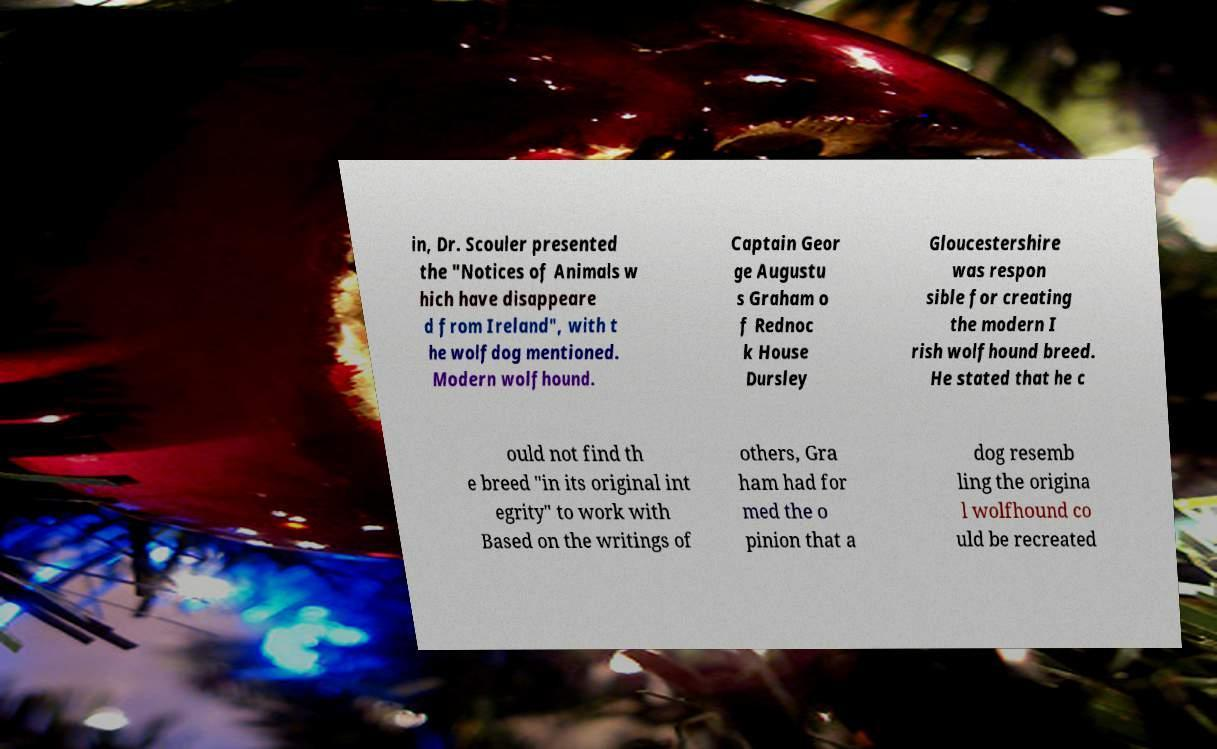Please identify and transcribe the text found in this image. in, Dr. Scouler presented the "Notices of Animals w hich have disappeare d from Ireland", with t he wolfdog mentioned. Modern wolfhound. Captain Geor ge Augustu s Graham o f Rednoc k House Dursley Gloucestershire was respon sible for creating the modern I rish wolfhound breed. He stated that he c ould not find th e breed "in its original int egrity" to work with Based on the writings of others, Gra ham had for med the o pinion that a dog resemb ling the origina l wolfhound co uld be recreated 